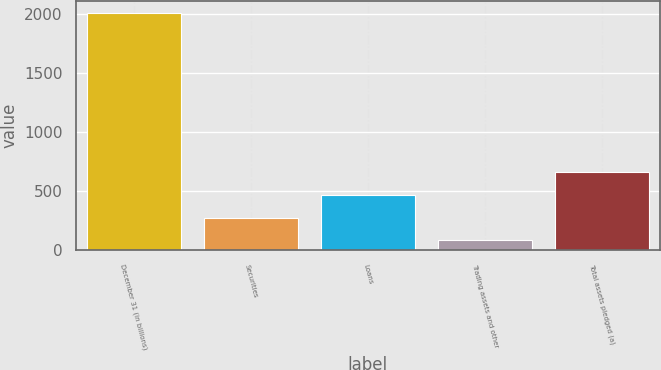Convert chart to OTSL. <chart><loc_0><loc_0><loc_500><loc_500><bar_chart><fcel>December 31 (in billions)<fcel>Securities<fcel>Loans<fcel>Trading assets and other<fcel>Total assets pledged (a)<nl><fcel>2009<fcel>277.04<fcel>469.48<fcel>84.6<fcel>661.92<nl></chart> 